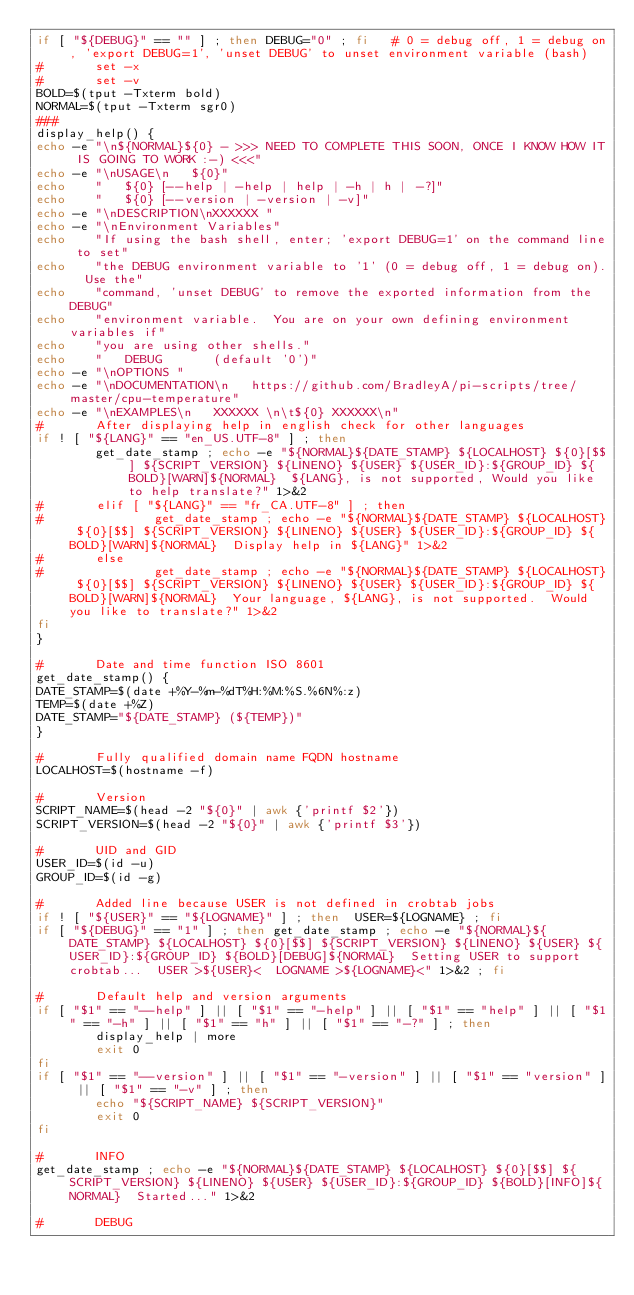<code> <loc_0><loc_0><loc_500><loc_500><_Bash_>if [ "${DEBUG}" == "" ] ; then DEBUG="0" ; fi   # 0 = debug off, 1 = debug on, 'export DEBUG=1', 'unset DEBUG' to unset environment variable (bash)
#       set -x
#       set -v
BOLD=$(tput -Txterm bold)
NORMAL=$(tput -Txterm sgr0)
###
display_help() {
echo -e "\n${NORMAL}${0} - >>> NEED TO COMPLETE THIS SOON, ONCE I KNOW HOW IT IS GOING TO WORK :-) <<<"
echo -e "\nUSAGE\n   ${0}"
echo    "   ${0} [--help | -help | help | -h | h | -?]"
echo    "   ${0} [--version | -version | -v]"
echo -e "\nDESCRIPTION\nXXXXXX "
echo -e "\nEnvironment Variables"
echo    "If using the bash shell, enter; 'export DEBUG=1' on the command line to set"
echo    "the DEBUG environment variable to '1' (0 = debug off, 1 = debug on).  Use the"
echo    "command, 'unset DEBUG' to remove the exported information from the DEBUG"
echo    "environment variable.  You are on your own defining environment variables if"
echo    "you are using other shells."
echo    "   DEBUG       (default '0')"
echo -e "\nOPTIONS "
echo -e "\nDOCUMENTATION\n   https://github.com/BradleyA/pi-scripts/tree/master/cpu-temperature"
echo -e "\nEXAMPLES\n   XXXXXX \n\t${0} XXXXXX\n"
#       After displaying help in english check for other languages
if ! [ "${LANG}" == "en_US.UTF-8" ] ; then
        get_date_stamp ; echo -e "${NORMAL}${DATE_STAMP} ${LOCALHOST} ${0}[$$] ${SCRIPT_VERSION} ${LINENO} ${USER} ${USER_ID}:${GROUP_ID} ${BOLD}[WARN]${NORMAL}  ${LANG}, is not supported, Would you like to help translate?" 1>&2
#       elif [ "${LANG}" == "fr_CA.UTF-8" ] ; then
#               get_date_stamp ; echo -e "${NORMAL}${DATE_STAMP} ${LOCALHOST} ${0}[$$] ${SCRIPT_VERSION} ${LINENO} ${USER} ${USER_ID}:${GROUP_ID} ${BOLD}[WARN]${NORMAL}  Display help in ${LANG}" 1>&2
#       else
#               get_date_stamp ; echo -e "${NORMAL}${DATE_STAMP} ${LOCALHOST} ${0}[$$] ${SCRIPT_VERSION} ${LINENO} ${USER} ${USER_ID}:${GROUP_ID} ${BOLD}[WARN]${NORMAL}  Your language, ${LANG}, is not supported.  Would you like to translate?" 1>&2
fi
}

#       Date and time function ISO 8601
get_date_stamp() {
DATE_STAMP=$(date +%Y-%m-%dT%H:%M:%S.%6N%:z)
TEMP=$(date +%Z)
DATE_STAMP="${DATE_STAMP} (${TEMP})"
}

#       Fully qualified domain name FQDN hostname
LOCALHOST=$(hostname -f)

#       Version
SCRIPT_NAME=$(head -2 "${0}" | awk {'printf $2'})
SCRIPT_VERSION=$(head -2 "${0}" | awk {'printf $3'})

#       UID and GID
USER_ID=$(id -u)
GROUP_ID=$(id -g)

#       Added line because USER is not defined in crobtab jobs
if ! [ "${USER}" == "${LOGNAME}" ] ; then  USER=${LOGNAME} ; fi
if [ "${DEBUG}" == "1" ] ; then get_date_stamp ; echo -e "${NORMAL}${DATE_STAMP} ${LOCALHOST} ${0}[$$] ${SCRIPT_VERSION} ${LINENO} ${USER} ${USER_ID}:${GROUP_ID} ${BOLD}[DEBUG]${NORMAL}  Setting USER to support crobtab...  USER >${USER}<  LOGNAME >${LOGNAME}<" 1>&2 ; fi

#       Default help and version arguments
if [ "$1" == "--help" ] || [ "$1" == "-help" ] || [ "$1" == "help" ] || [ "$1" == "-h" ] || [ "$1" == "h" ] || [ "$1" == "-?" ] ; then
        display_help | more
        exit 0
fi
if [ "$1" == "--version" ] || [ "$1" == "-version" ] || [ "$1" == "version" ] || [ "$1" == "-v" ] ; then
        echo "${SCRIPT_NAME} ${SCRIPT_VERSION}"
        exit 0
fi

#       INFO
get_date_stamp ; echo -e "${NORMAL}${DATE_STAMP} ${LOCALHOST} ${0}[$$] ${SCRIPT_VERSION} ${LINENO} ${USER} ${USER_ID}:${GROUP_ID} ${BOLD}[INFO]${NORMAL}  Started..." 1>&2

#       DEBUG</code> 